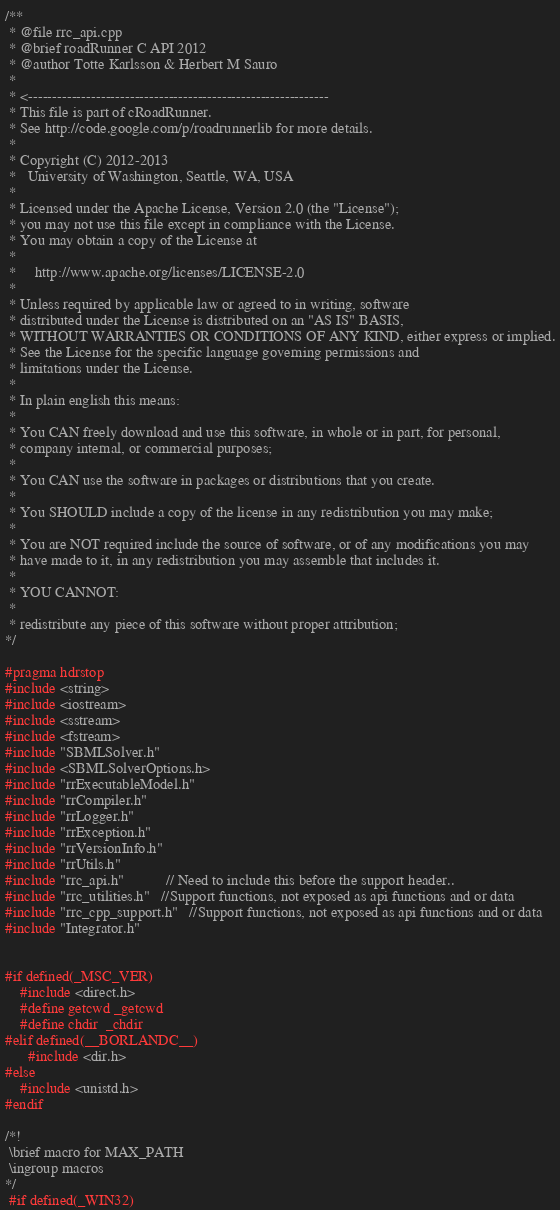<code> <loc_0><loc_0><loc_500><loc_500><_C++_>/**
 * @file rrc_api.cpp
 * @brief roadRunner C API 2012
 * @author Totte Karlsson & Herbert M Sauro
 *
 * <--------------------------------------------------------------
 * This file is part of cRoadRunner.
 * See http://code.google.com/p/roadrunnerlib for more details.
 *
 * Copyright (C) 2012-2013
 *   University of Washington, Seattle, WA, USA
 *
 * Licensed under the Apache License, Version 2.0 (the "License");
 * you may not use this file except in compliance with the License.
 * You may obtain a copy of the License at
 *
 *     http://www.apache.org/licenses/LICENSE-2.0
 *
 * Unless required by applicable law or agreed to in writing, software
 * distributed under the License is distributed on an "AS IS" BASIS,
 * WITHOUT WARRANTIES OR CONDITIONS OF ANY KIND, either express or implied.
 * See the License for the specific language governing permissions and
 * limitations under the License.
 *
 * In plain english this means:
 *
 * You CAN freely download and use this software, in whole or in part, for personal,
 * company internal, or commercial purposes;
 *
 * You CAN use the software in packages or distributions that you create.
 *
 * You SHOULD include a copy of the license in any redistribution you may make;
 *
 * You are NOT required include the source of software, or of any modifications you may
 * have made to it, in any redistribution you may assemble that includes it.
 *
 * YOU CANNOT:
 *
 * redistribute any piece of this software without proper attribution;
*/

#pragma hdrstop
#include <string>
#include <iostream>
#include <sstream>
#include <fstream>
#include "SBMLSolver.h"
#include <SBMLSolverOptions.h>
#include "rrExecutableModel.h"
#include "rrCompiler.h"
#include "rrLogger.h"
#include "rrException.h"
#include "rrVersionInfo.h"
#include "rrUtils.h"
#include "rrc_api.h"           // Need to include this before the support header..
#include "rrc_utilities.h"   //Support functions, not exposed as api functions and or data
#include "rrc_cpp_support.h"   //Support functions, not exposed as api functions and or data
#include "Integrator.h"


#if defined(_MSC_VER)
    #include <direct.h>
    #define getcwd _getcwd
    #define chdir  _chdir
#elif defined(__BORLANDC__)
      #include <dir.h>
#else
    #include <unistd.h>
#endif

/*!
 \brief macro for MAX_PATH
 \ingroup macros
*/
 #if defined(_WIN32)</code> 